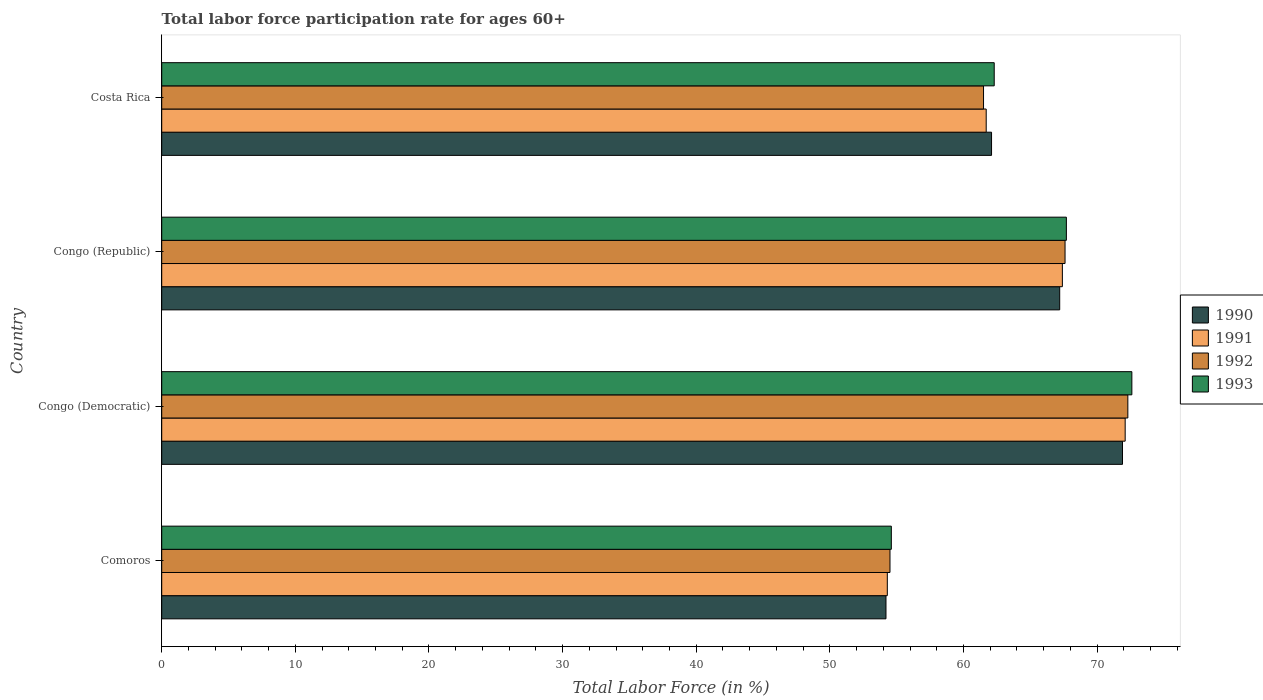Are the number of bars on each tick of the Y-axis equal?
Your answer should be compact. Yes. How many bars are there on the 1st tick from the top?
Provide a succinct answer. 4. How many bars are there on the 1st tick from the bottom?
Provide a short and direct response. 4. What is the label of the 1st group of bars from the top?
Your answer should be compact. Costa Rica. What is the labor force participation rate in 1992 in Congo (Republic)?
Provide a succinct answer. 67.6. Across all countries, what is the maximum labor force participation rate in 1991?
Provide a succinct answer. 72.1. Across all countries, what is the minimum labor force participation rate in 1993?
Provide a short and direct response. 54.6. In which country was the labor force participation rate in 1993 maximum?
Offer a very short reply. Congo (Democratic). In which country was the labor force participation rate in 1991 minimum?
Make the answer very short. Comoros. What is the total labor force participation rate in 1992 in the graph?
Your answer should be very brief. 255.9. What is the difference between the labor force participation rate in 1990 in Comoros and that in Congo (Democratic)?
Provide a succinct answer. -17.7. What is the difference between the labor force participation rate in 1991 in Comoros and the labor force participation rate in 1992 in Congo (Republic)?
Provide a succinct answer. -13.3. What is the average labor force participation rate in 1992 per country?
Offer a very short reply. 63.98. What is the difference between the labor force participation rate in 1992 and labor force participation rate in 1990 in Congo (Republic)?
Ensure brevity in your answer.  0.4. In how many countries, is the labor force participation rate in 1993 greater than 22 %?
Keep it short and to the point. 4. What is the ratio of the labor force participation rate in 1991 in Comoros to that in Costa Rica?
Give a very brief answer. 0.88. Is the labor force participation rate in 1990 in Comoros less than that in Congo (Democratic)?
Keep it short and to the point. Yes. What is the difference between the highest and the second highest labor force participation rate in 1990?
Offer a very short reply. 4.7. What is the difference between the highest and the lowest labor force participation rate in 1993?
Your response must be concise. 18. In how many countries, is the labor force participation rate in 1993 greater than the average labor force participation rate in 1993 taken over all countries?
Your answer should be compact. 2. Is the sum of the labor force participation rate in 1993 in Comoros and Costa Rica greater than the maximum labor force participation rate in 1990 across all countries?
Make the answer very short. Yes. Is it the case that in every country, the sum of the labor force participation rate in 1991 and labor force participation rate in 1992 is greater than the sum of labor force participation rate in 1993 and labor force participation rate in 1990?
Your answer should be very brief. No. What does the 4th bar from the top in Costa Rica represents?
Keep it short and to the point. 1990. What does the 1st bar from the bottom in Congo (Democratic) represents?
Offer a terse response. 1990. How many bars are there?
Keep it short and to the point. 16. Are all the bars in the graph horizontal?
Your answer should be very brief. Yes. What is the difference between two consecutive major ticks on the X-axis?
Ensure brevity in your answer.  10. Are the values on the major ticks of X-axis written in scientific E-notation?
Give a very brief answer. No. Does the graph contain any zero values?
Provide a short and direct response. No. Where does the legend appear in the graph?
Your answer should be very brief. Center right. How are the legend labels stacked?
Keep it short and to the point. Vertical. What is the title of the graph?
Give a very brief answer. Total labor force participation rate for ages 60+. Does "2015" appear as one of the legend labels in the graph?
Offer a very short reply. No. What is the label or title of the X-axis?
Your answer should be compact. Total Labor Force (in %). What is the label or title of the Y-axis?
Provide a succinct answer. Country. What is the Total Labor Force (in %) in 1990 in Comoros?
Your answer should be very brief. 54.2. What is the Total Labor Force (in %) of 1991 in Comoros?
Offer a terse response. 54.3. What is the Total Labor Force (in %) of 1992 in Comoros?
Your response must be concise. 54.5. What is the Total Labor Force (in %) of 1993 in Comoros?
Provide a succinct answer. 54.6. What is the Total Labor Force (in %) of 1990 in Congo (Democratic)?
Make the answer very short. 71.9. What is the Total Labor Force (in %) in 1991 in Congo (Democratic)?
Provide a short and direct response. 72.1. What is the Total Labor Force (in %) of 1992 in Congo (Democratic)?
Keep it short and to the point. 72.3. What is the Total Labor Force (in %) in 1993 in Congo (Democratic)?
Your response must be concise. 72.6. What is the Total Labor Force (in %) of 1990 in Congo (Republic)?
Give a very brief answer. 67.2. What is the Total Labor Force (in %) in 1991 in Congo (Republic)?
Offer a very short reply. 67.4. What is the Total Labor Force (in %) of 1992 in Congo (Republic)?
Offer a terse response. 67.6. What is the Total Labor Force (in %) in 1993 in Congo (Republic)?
Keep it short and to the point. 67.7. What is the Total Labor Force (in %) of 1990 in Costa Rica?
Give a very brief answer. 62.1. What is the Total Labor Force (in %) of 1991 in Costa Rica?
Provide a short and direct response. 61.7. What is the Total Labor Force (in %) of 1992 in Costa Rica?
Your answer should be very brief. 61.5. What is the Total Labor Force (in %) in 1993 in Costa Rica?
Give a very brief answer. 62.3. Across all countries, what is the maximum Total Labor Force (in %) of 1990?
Provide a short and direct response. 71.9. Across all countries, what is the maximum Total Labor Force (in %) in 1991?
Offer a terse response. 72.1. Across all countries, what is the maximum Total Labor Force (in %) of 1992?
Offer a very short reply. 72.3. Across all countries, what is the maximum Total Labor Force (in %) of 1993?
Give a very brief answer. 72.6. Across all countries, what is the minimum Total Labor Force (in %) of 1990?
Offer a terse response. 54.2. Across all countries, what is the minimum Total Labor Force (in %) of 1991?
Give a very brief answer. 54.3. Across all countries, what is the minimum Total Labor Force (in %) of 1992?
Your answer should be very brief. 54.5. Across all countries, what is the minimum Total Labor Force (in %) in 1993?
Offer a terse response. 54.6. What is the total Total Labor Force (in %) of 1990 in the graph?
Offer a very short reply. 255.4. What is the total Total Labor Force (in %) in 1991 in the graph?
Give a very brief answer. 255.5. What is the total Total Labor Force (in %) in 1992 in the graph?
Make the answer very short. 255.9. What is the total Total Labor Force (in %) of 1993 in the graph?
Keep it short and to the point. 257.2. What is the difference between the Total Labor Force (in %) of 1990 in Comoros and that in Congo (Democratic)?
Provide a succinct answer. -17.7. What is the difference between the Total Labor Force (in %) in 1991 in Comoros and that in Congo (Democratic)?
Your answer should be compact. -17.8. What is the difference between the Total Labor Force (in %) of 1992 in Comoros and that in Congo (Democratic)?
Give a very brief answer. -17.8. What is the difference between the Total Labor Force (in %) of 1990 in Comoros and that in Congo (Republic)?
Make the answer very short. -13. What is the difference between the Total Labor Force (in %) in 1992 in Comoros and that in Congo (Republic)?
Your answer should be compact. -13.1. What is the difference between the Total Labor Force (in %) in 1993 in Comoros and that in Congo (Republic)?
Offer a very short reply. -13.1. What is the difference between the Total Labor Force (in %) of 1991 in Comoros and that in Costa Rica?
Offer a terse response. -7.4. What is the difference between the Total Labor Force (in %) of 1992 in Comoros and that in Costa Rica?
Give a very brief answer. -7. What is the difference between the Total Labor Force (in %) of 1993 in Comoros and that in Costa Rica?
Provide a short and direct response. -7.7. What is the difference between the Total Labor Force (in %) of 1990 in Congo (Democratic) and that in Congo (Republic)?
Your response must be concise. 4.7. What is the difference between the Total Labor Force (in %) of 1992 in Congo (Democratic) and that in Congo (Republic)?
Provide a short and direct response. 4.7. What is the difference between the Total Labor Force (in %) in 1993 in Congo (Democratic) and that in Congo (Republic)?
Give a very brief answer. 4.9. What is the difference between the Total Labor Force (in %) in 1990 in Congo (Democratic) and that in Costa Rica?
Provide a succinct answer. 9.8. What is the difference between the Total Labor Force (in %) in 1992 in Congo (Democratic) and that in Costa Rica?
Your answer should be very brief. 10.8. What is the difference between the Total Labor Force (in %) of 1991 in Congo (Republic) and that in Costa Rica?
Keep it short and to the point. 5.7. What is the difference between the Total Labor Force (in %) of 1993 in Congo (Republic) and that in Costa Rica?
Keep it short and to the point. 5.4. What is the difference between the Total Labor Force (in %) of 1990 in Comoros and the Total Labor Force (in %) of 1991 in Congo (Democratic)?
Give a very brief answer. -17.9. What is the difference between the Total Labor Force (in %) in 1990 in Comoros and the Total Labor Force (in %) in 1992 in Congo (Democratic)?
Provide a succinct answer. -18.1. What is the difference between the Total Labor Force (in %) in 1990 in Comoros and the Total Labor Force (in %) in 1993 in Congo (Democratic)?
Make the answer very short. -18.4. What is the difference between the Total Labor Force (in %) in 1991 in Comoros and the Total Labor Force (in %) in 1992 in Congo (Democratic)?
Ensure brevity in your answer.  -18. What is the difference between the Total Labor Force (in %) in 1991 in Comoros and the Total Labor Force (in %) in 1993 in Congo (Democratic)?
Give a very brief answer. -18.3. What is the difference between the Total Labor Force (in %) in 1992 in Comoros and the Total Labor Force (in %) in 1993 in Congo (Democratic)?
Your answer should be compact. -18.1. What is the difference between the Total Labor Force (in %) in 1990 in Comoros and the Total Labor Force (in %) in 1992 in Congo (Republic)?
Provide a succinct answer. -13.4. What is the difference between the Total Labor Force (in %) in 1990 in Comoros and the Total Labor Force (in %) in 1993 in Congo (Republic)?
Your answer should be compact. -13.5. What is the difference between the Total Labor Force (in %) in 1991 in Comoros and the Total Labor Force (in %) in 1992 in Congo (Republic)?
Make the answer very short. -13.3. What is the difference between the Total Labor Force (in %) in 1991 in Comoros and the Total Labor Force (in %) in 1993 in Congo (Republic)?
Ensure brevity in your answer.  -13.4. What is the difference between the Total Labor Force (in %) in 1990 in Comoros and the Total Labor Force (in %) in 1991 in Costa Rica?
Provide a short and direct response. -7.5. What is the difference between the Total Labor Force (in %) in 1990 in Comoros and the Total Labor Force (in %) in 1992 in Costa Rica?
Make the answer very short. -7.3. What is the difference between the Total Labor Force (in %) in 1990 in Comoros and the Total Labor Force (in %) in 1993 in Costa Rica?
Give a very brief answer. -8.1. What is the difference between the Total Labor Force (in %) in 1991 in Comoros and the Total Labor Force (in %) in 1992 in Costa Rica?
Your answer should be compact. -7.2. What is the difference between the Total Labor Force (in %) of 1991 in Comoros and the Total Labor Force (in %) of 1993 in Costa Rica?
Keep it short and to the point. -8. What is the difference between the Total Labor Force (in %) in 1990 in Congo (Democratic) and the Total Labor Force (in %) in 1991 in Congo (Republic)?
Make the answer very short. 4.5. What is the difference between the Total Labor Force (in %) in 1990 in Congo (Democratic) and the Total Labor Force (in %) in 1992 in Congo (Republic)?
Your answer should be compact. 4.3. What is the difference between the Total Labor Force (in %) of 1991 in Congo (Democratic) and the Total Labor Force (in %) of 1992 in Congo (Republic)?
Offer a very short reply. 4.5. What is the difference between the Total Labor Force (in %) of 1992 in Congo (Democratic) and the Total Labor Force (in %) of 1993 in Congo (Republic)?
Provide a short and direct response. 4.6. What is the difference between the Total Labor Force (in %) in 1990 in Congo (Democratic) and the Total Labor Force (in %) in 1992 in Costa Rica?
Offer a terse response. 10.4. What is the difference between the Total Labor Force (in %) of 1990 in Congo (Democratic) and the Total Labor Force (in %) of 1993 in Costa Rica?
Provide a succinct answer. 9.6. What is the difference between the Total Labor Force (in %) of 1991 in Congo (Democratic) and the Total Labor Force (in %) of 1992 in Costa Rica?
Your answer should be very brief. 10.6. What is the difference between the Total Labor Force (in %) of 1991 in Congo (Democratic) and the Total Labor Force (in %) of 1993 in Costa Rica?
Keep it short and to the point. 9.8. What is the difference between the Total Labor Force (in %) in 1992 in Congo (Democratic) and the Total Labor Force (in %) in 1993 in Costa Rica?
Give a very brief answer. 10. What is the difference between the Total Labor Force (in %) in 1991 in Congo (Republic) and the Total Labor Force (in %) in 1992 in Costa Rica?
Your response must be concise. 5.9. What is the average Total Labor Force (in %) in 1990 per country?
Your answer should be very brief. 63.85. What is the average Total Labor Force (in %) in 1991 per country?
Your answer should be compact. 63.88. What is the average Total Labor Force (in %) of 1992 per country?
Offer a very short reply. 63.98. What is the average Total Labor Force (in %) of 1993 per country?
Make the answer very short. 64.3. What is the difference between the Total Labor Force (in %) in 1990 and Total Labor Force (in %) in 1991 in Comoros?
Your answer should be very brief. -0.1. What is the difference between the Total Labor Force (in %) in 1991 and Total Labor Force (in %) in 1992 in Comoros?
Provide a succinct answer. -0.2. What is the difference between the Total Labor Force (in %) of 1990 and Total Labor Force (in %) of 1992 in Congo (Democratic)?
Your answer should be very brief. -0.4. What is the difference between the Total Labor Force (in %) in 1991 and Total Labor Force (in %) in 1992 in Congo (Democratic)?
Keep it short and to the point. -0.2. What is the difference between the Total Labor Force (in %) of 1992 and Total Labor Force (in %) of 1993 in Congo (Democratic)?
Keep it short and to the point. -0.3. What is the difference between the Total Labor Force (in %) in 1990 and Total Labor Force (in %) in 1991 in Congo (Republic)?
Make the answer very short. -0.2. What is the difference between the Total Labor Force (in %) of 1991 and Total Labor Force (in %) of 1992 in Congo (Republic)?
Ensure brevity in your answer.  -0.2. What is the difference between the Total Labor Force (in %) of 1991 and Total Labor Force (in %) of 1993 in Congo (Republic)?
Provide a succinct answer. -0.3. What is the difference between the Total Labor Force (in %) of 1992 and Total Labor Force (in %) of 1993 in Congo (Republic)?
Your answer should be compact. -0.1. What is the difference between the Total Labor Force (in %) in 1990 and Total Labor Force (in %) in 1993 in Costa Rica?
Your answer should be compact. -0.2. What is the difference between the Total Labor Force (in %) of 1992 and Total Labor Force (in %) of 1993 in Costa Rica?
Provide a short and direct response. -0.8. What is the ratio of the Total Labor Force (in %) in 1990 in Comoros to that in Congo (Democratic)?
Give a very brief answer. 0.75. What is the ratio of the Total Labor Force (in %) of 1991 in Comoros to that in Congo (Democratic)?
Your response must be concise. 0.75. What is the ratio of the Total Labor Force (in %) in 1992 in Comoros to that in Congo (Democratic)?
Make the answer very short. 0.75. What is the ratio of the Total Labor Force (in %) in 1993 in Comoros to that in Congo (Democratic)?
Give a very brief answer. 0.75. What is the ratio of the Total Labor Force (in %) in 1990 in Comoros to that in Congo (Republic)?
Keep it short and to the point. 0.81. What is the ratio of the Total Labor Force (in %) in 1991 in Comoros to that in Congo (Republic)?
Offer a very short reply. 0.81. What is the ratio of the Total Labor Force (in %) in 1992 in Comoros to that in Congo (Republic)?
Your response must be concise. 0.81. What is the ratio of the Total Labor Force (in %) in 1993 in Comoros to that in Congo (Republic)?
Your answer should be very brief. 0.81. What is the ratio of the Total Labor Force (in %) of 1990 in Comoros to that in Costa Rica?
Your response must be concise. 0.87. What is the ratio of the Total Labor Force (in %) of 1991 in Comoros to that in Costa Rica?
Your answer should be very brief. 0.88. What is the ratio of the Total Labor Force (in %) in 1992 in Comoros to that in Costa Rica?
Make the answer very short. 0.89. What is the ratio of the Total Labor Force (in %) in 1993 in Comoros to that in Costa Rica?
Offer a very short reply. 0.88. What is the ratio of the Total Labor Force (in %) of 1990 in Congo (Democratic) to that in Congo (Republic)?
Ensure brevity in your answer.  1.07. What is the ratio of the Total Labor Force (in %) in 1991 in Congo (Democratic) to that in Congo (Republic)?
Offer a very short reply. 1.07. What is the ratio of the Total Labor Force (in %) of 1992 in Congo (Democratic) to that in Congo (Republic)?
Provide a short and direct response. 1.07. What is the ratio of the Total Labor Force (in %) in 1993 in Congo (Democratic) to that in Congo (Republic)?
Ensure brevity in your answer.  1.07. What is the ratio of the Total Labor Force (in %) of 1990 in Congo (Democratic) to that in Costa Rica?
Keep it short and to the point. 1.16. What is the ratio of the Total Labor Force (in %) in 1991 in Congo (Democratic) to that in Costa Rica?
Your answer should be very brief. 1.17. What is the ratio of the Total Labor Force (in %) in 1992 in Congo (Democratic) to that in Costa Rica?
Your answer should be very brief. 1.18. What is the ratio of the Total Labor Force (in %) of 1993 in Congo (Democratic) to that in Costa Rica?
Your answer should be very brief. 1.17. What is the ratio of the Total Labor Force (in %) in 1990 in Congo (Republic) to that in Costa Rica?
Give a very brief answer. 1.08. What is the ratio of the Total Labor Force (in %) of 1991 in Congo (Republic) to that in Costa Rica?
Your answer should be compact. 1.09. What is the ratio of the Total Labor Force (in %) of 1992 in Congo (Republic) to that in Costa Rica?
Your answer should be very brief. 1.1. What is the ratio of the Total Labor Force (in %) of 1993 in Congo (Republic) to that in Costa Rica?
Your answer should be compact. 1.09. What is the difference between the highest and the second highest Total Labor Force (in %) in 1990?
Offer a terse response. 4.7. What is the difference between the highest and the second highest Total Labor Force (in %) in 1991?
Offer a terse response. 4.7. What is the difference between the highest and the lowest Total Labor Force (in %) of 1990?
Offer a very short reply. 17.7. What is the difference between the highest and the lowest Total Labor Force (in %) in 1991?
Provide a short and direct response. 17.8. What is the difference between the highest and the lowest Total Labor Force (in %) of 1992?
Ensure brevity in your answer.  17.8. 